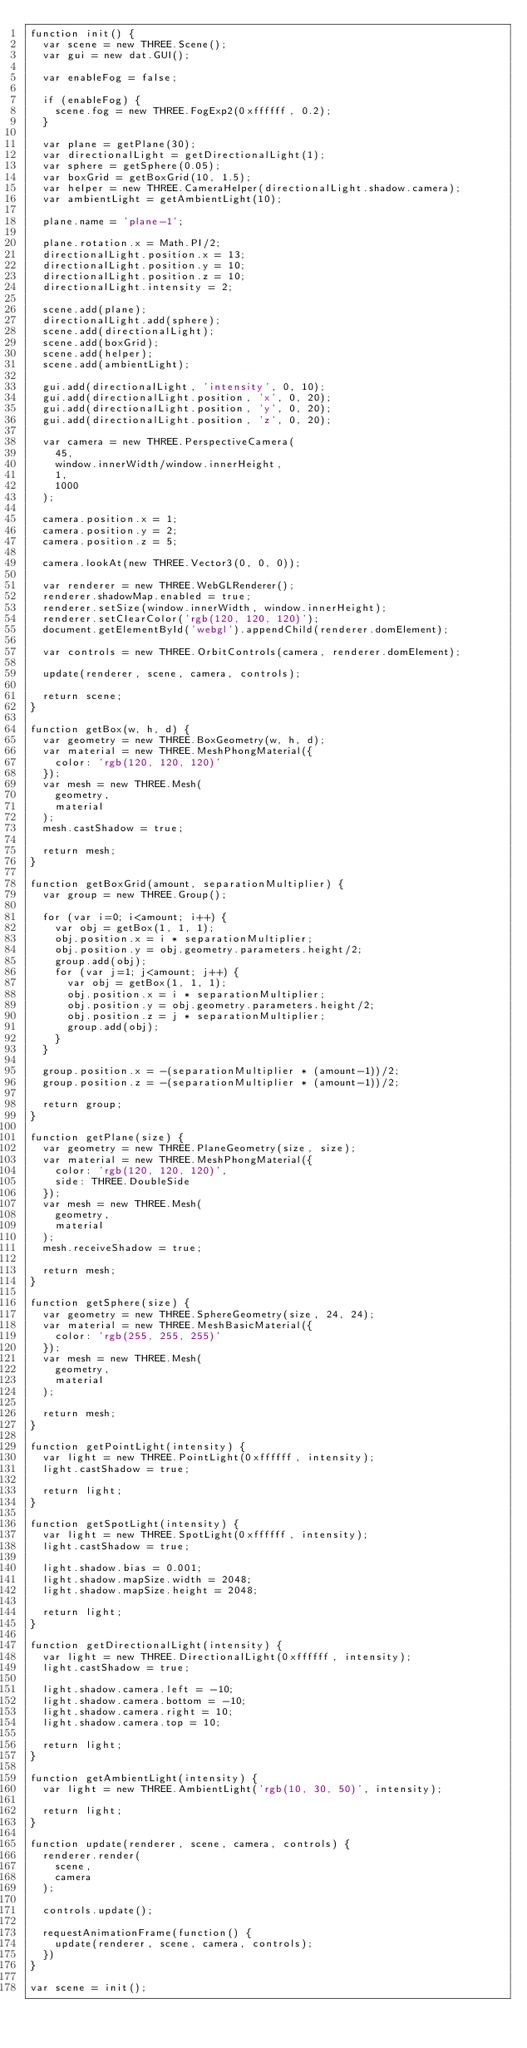Convert code to text. <code><loc_0><loc_0><loc_500><loc_500><_JavaScript_>function init() {
	var scene = new THREE.Scene();
	var gui = new dat.GUI();

	var enableFog = false;

	if (enableFog) {
		scene.fog = new THREE.FogExp2(0xffffff, 0.2);
	}
	
	var plane = getPlane(30);
	var directionalLight = getDirectionalLight(1);
	var sphere = getSphere(0.05);
	var boxGrid = getBoxGrid(10, 1.5);
	var helper = new THREE.CameraHelper(directionalLight.shadow.camera);
	var ambientLight = getAmbientLight(10);

	plane.name = 'plane-1';

	plane.rotation.x = Math.PI/2;
	directionalLight.position.x = 13;
	directionalLight.position.y = 10;
	directionalLight.position.z = 10;
	directionalLight.intensity = 2;

	scene.add(plane);
	directionalLight.add(sphere);
	scene.add(directionalLight);
	scene.add(boxGrid);
	scene.add(helper);
	scene.add(ambientLight);

	gui.add(directionalLight, 'intensity', 0, 10);
	gui.add(directionalLight.position, 'x', 0, 20);
	gui.add(directionalLight.position, 'y', 0, 20);
	gui.add(directionalLight.position, 'z', 0, 20);

	var camera = new THREE.PerspectiveCamera(
		45,
		window.innerWidth/window.innerHeight,
		1,
		1000
	);

	camera.position.x = 1;
	camera.position.y = 2;
	camera.position.z = 5;

	camera.lookAt(new THREE.Vector3(0, 0, 0));

	var renderer = new THREE.WebGLRenderer();
	renderer.shadowMap.enabled = true;
	renderer.setSize(window.innerWidth, window.innerHeight);
	renderer.setClearColor('rgb(120, 120, 120)');
	document.getElementById('webgl').appendChild(renderer.domElement);

	var controls = new THREE.OrbitControls(camera, renderer.domElement);

	update(renderer, scene, camera, controls);

	return scene;
}

function getBox(w, h, d) {
	var geometry = new THREE.BoxGeometry(w, h, d);
	var material = new THREE.MeshPhongMaterial({
		color: 'rgb(120, 120, 120)'
	});
	var mesh = new THREE.Mesh(
		geometry,
		material 
	);
	mesh.castShadow = true;

	return mesh;
}

function getBoxGrid(amount, separationMultiplier) {
	var group = new THREE.Group();

	for (var i=0; i<amount; i++) {
		var obj = getBox(1, 1, 1);
		obj.position.x = i * separationMultiplier;
		obj.position.y = obj.geometry.parameters.height/2;
		group.add(obj);
		for (var j=1; j<amount; j++) {
			var obj = getBox(1, 1, 1);
			obj.position.x = i * separationMultiplier;
			obj.position.y = obj.geometry.parameters.height/2;
			obj.position.z = j * separationMultiplier;
			group.add(obj);
		}
	}

	group.position.x = -(separationMultiplier * (amount-1))/2;
	group.position.z = -(separationMultiplier * (amount-1))/2;

	return group;
}

function getPlane(size) {
	var geometry = new THREE.PlaneGeometry(size, size);
	var material = new THREE.MeshPhongMaterial({
		color: 'rgb(120, 120, 120)',
		side: THREE.DoubleSide
	});
	var mesh = new THREE.Mesh(
		geometry,
		material 
	);
	mesh.receiveShadow = true;

	return mesh;
}

function getSphere(size) {
	var geometry = new THREE.SphereGeometry(size, 24, 24);
	var material = new THREE.MeshBasicMaterial({
		color: 'rgb(255, 255, 255)'
	});
	var mesh = new THREE.Mesh(
		geometry,
		material 
	);

	return mesh;
}

function getPointLight(intensity) {
	var light = new THREE.PointLight(0xffffff, intensity);
	light.castShadow = true;

	return light;
}

function getSpotLight(intensity) {
	var light = new THREE.SpotLight(0xffffff, intensity);
	light.castShadow = true;

	light.shadow.bias = 0.001;
	light.shadow.mapSize.width = 2048;
	light.shadow.mapSize.height = 2048;

	return light;
}

function getDirectionalLight(intensity) {
	var light = new THREE.DirectionalLight(0xffffff, intensity);
	light.castShadow = true;

	light.shadow.camera.left = -10;
	light.shadow.camera.bottom = -10;
	light.shadow.camera.right = 10;
	light.shadow.camera.top = 10;

	return light;
}

function getAmbientLight(intensity) {
	var light = new THREE.AmbientLight('rgb(10, 30, 50)', intensity);

	return light;
}

function update(renderer, scene, camera, controls) {
	renderer.render(
		scene,
		camera
	);

	controls.update();

	requestAnimationFrame(function() {
		update(renderer, scene, camera, controls);
	})
}

var scene = init();</code> 